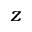<formula> <loc_0><loc_0><loc_500><loc_500>z</formula> 